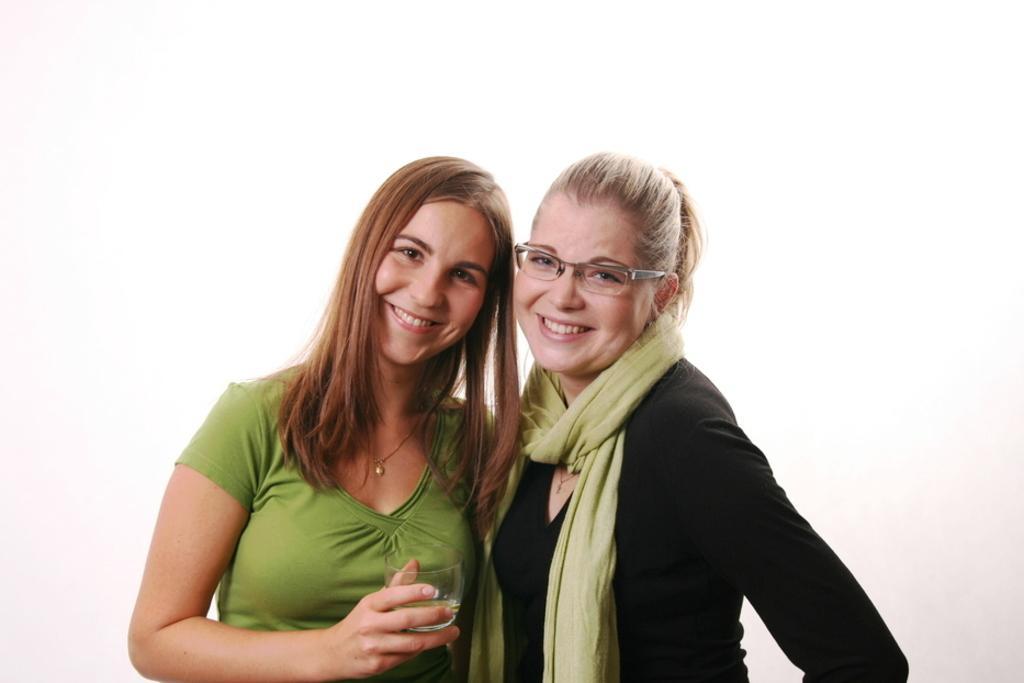In one or two sentences, can you explain what this image depicts? In the picture I can see a woman wearing green color T-shirt is holding a glass in her hands and standing on the left side of the image and we can see a woman wearing black color dress, scarf and spectacles is standing on the right side of the image. They both are smiling. The background of the image is in white color. 